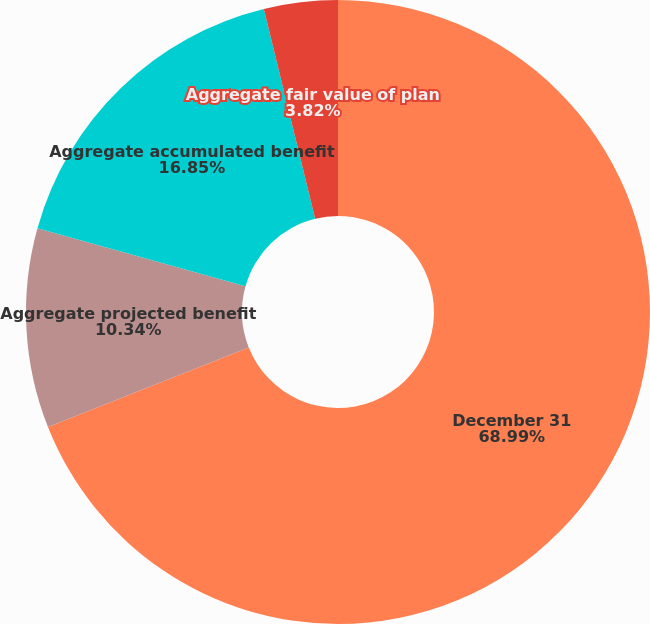Convert chart to OTSL. <chart><loc_0><loc_0><loc_500><loc_500><pie_chart><fcel>December 31<fcel>Aggregate projected benefit<fcel>Aggregate accumulated benefit<fcel>Aggregate fair value of plan<nl><fcel>68.99%<fcel>10.34%<fcel>16.85%<fcel>3.82%<nl></chart> 